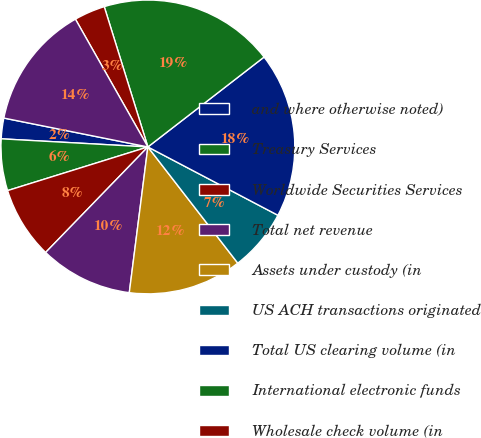Convert chart to OTSL. <chart><loc_0><loc_0><loc_500><loc_500><pie_chart><fcel>and where otherwise noted)<fcel>Treasury Services<fcel>Worldwide Securities Services<fcel>Total net revenue<fcel>Assets under custody (in<fcel>US ACH transactions originated<fcel>Total US clearing volume (in<fcel>International electronic funds<fcel>Wholesale check volume (in<fcel>Wholesale cards issued (in<nl><fcel>2.27%<fcel>5.68%<fcel>7.95%<fcel>10.23%<fcel>12.5%<fcel>6.82%<fcel>18.18%<fcel>19.32%<fcel>3.41%<fcel>13.64%<nl></chart> 